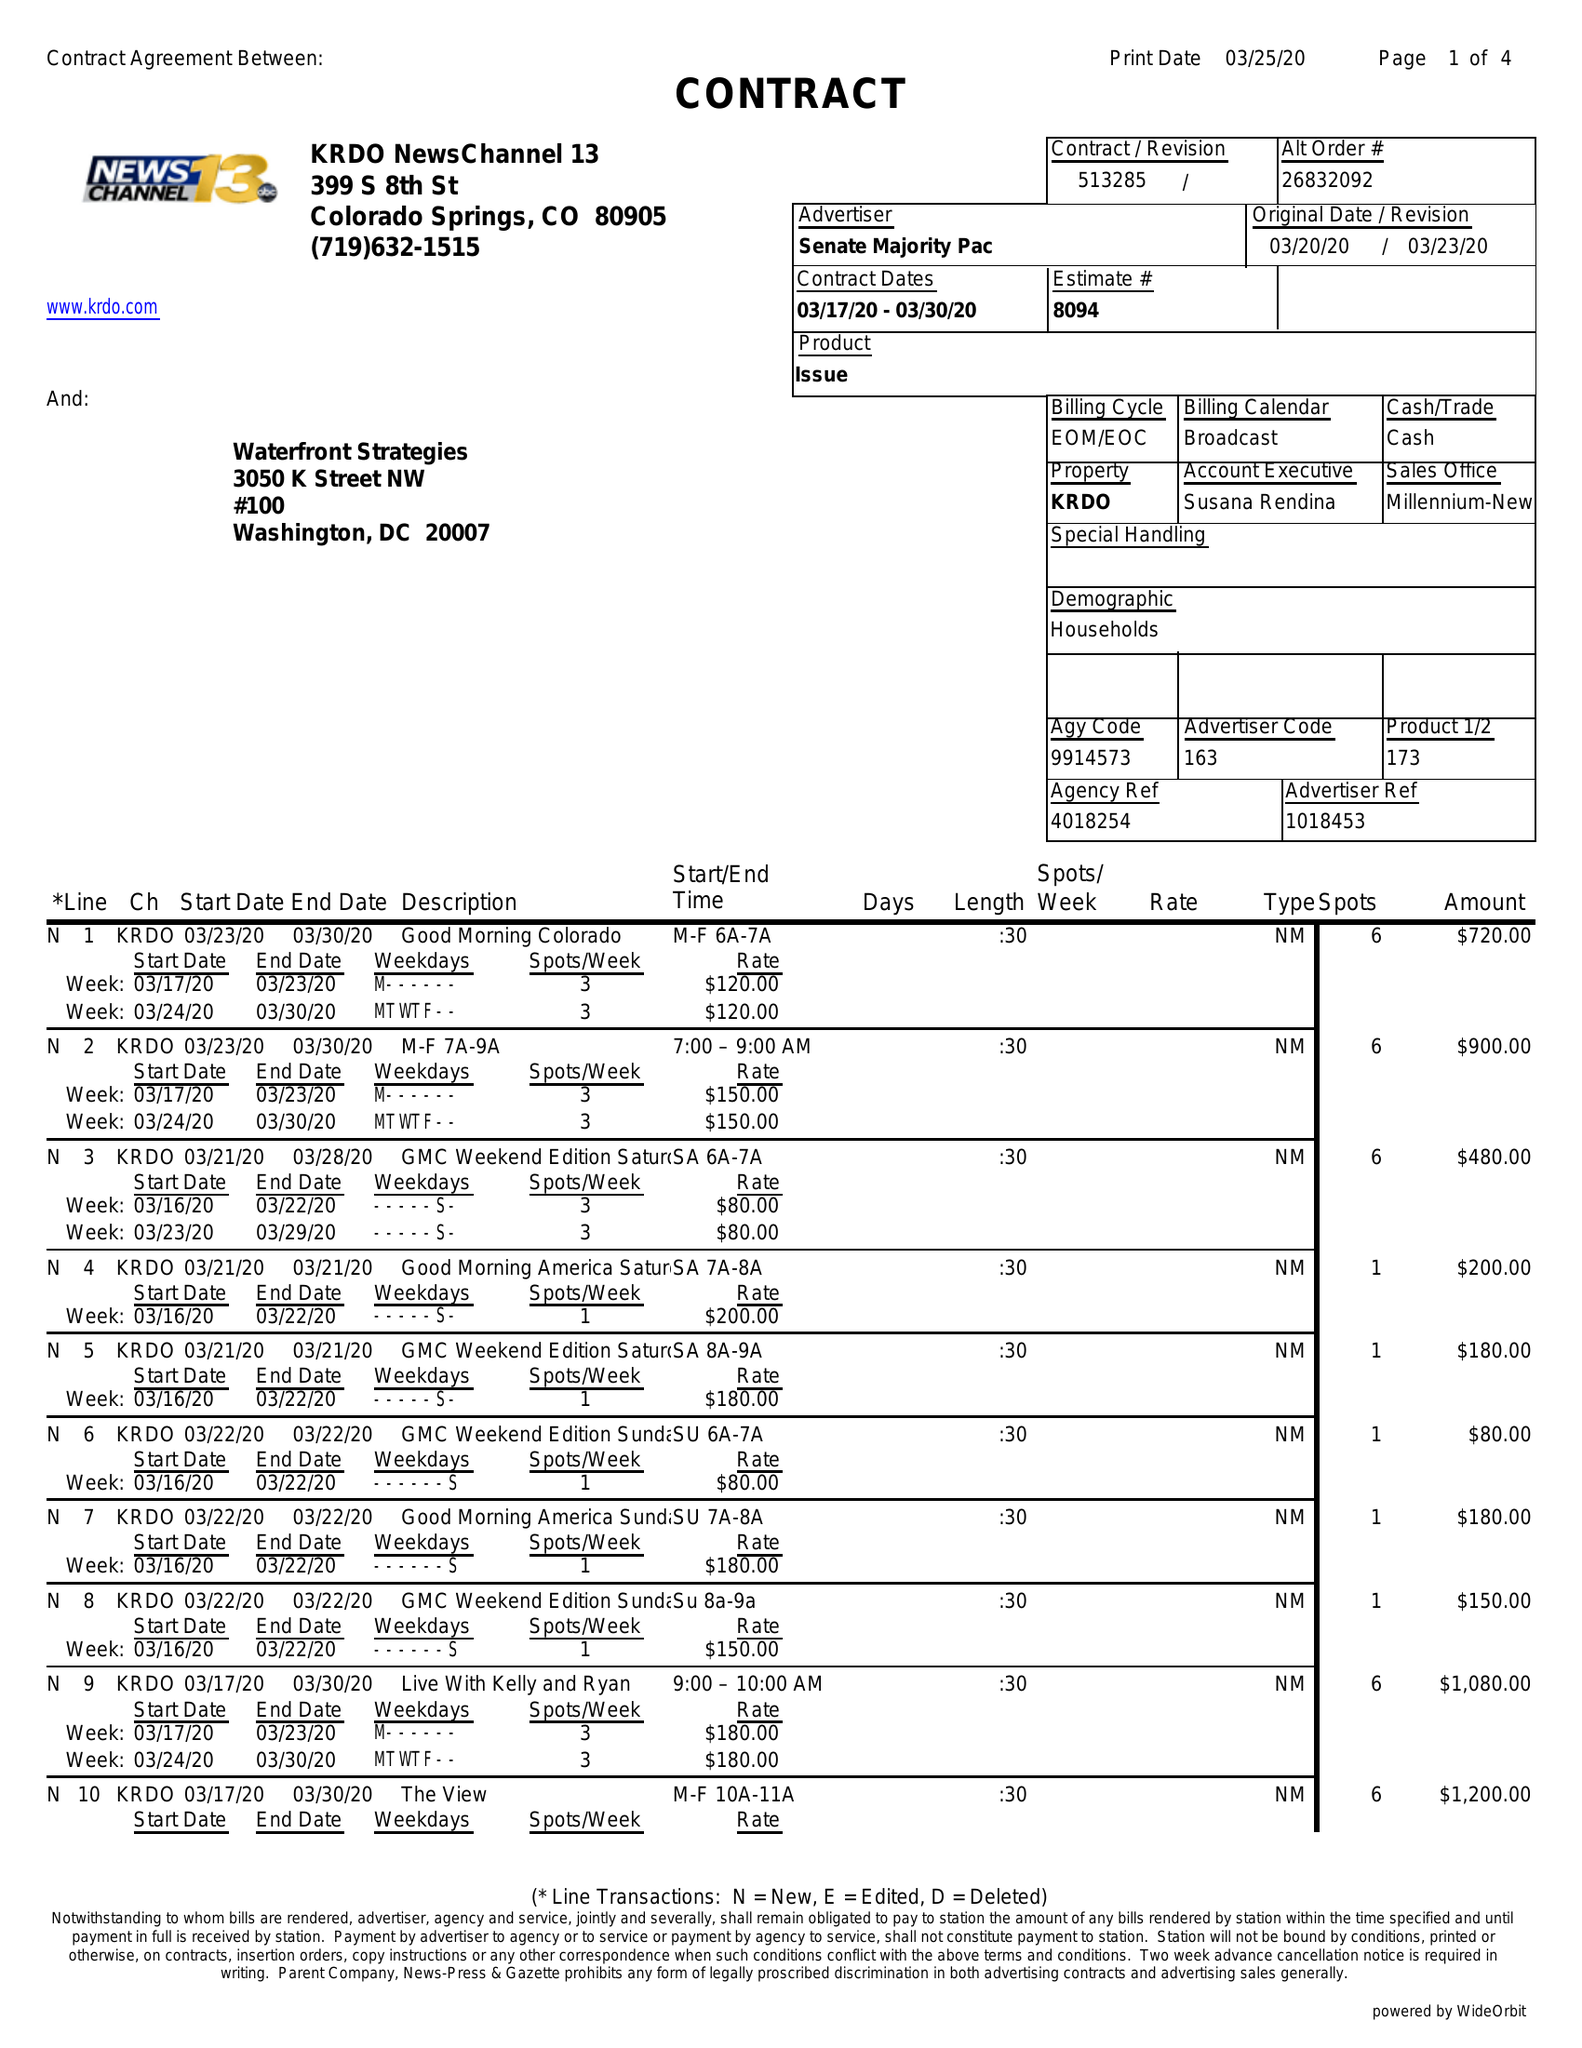What is the value for the contract_num?
Answer the question using a single word or phrase. 513285 